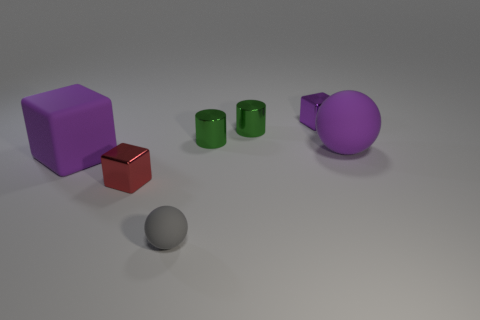Add 2 large brown metallic spheres. How many objects exist? 9 Subtract all cubes. How many objects are left? 4 Add 3 large cubes. How many large cubes exist? 4 Subtract 2 green cylinders. How many objects are left? 5 Subtract all red blocks. Subtract all small purple metallic cubes. How many objects are left? 5 Add 3 tiny green shiny cylinders. How many tiny green shiny cylinders are left? 5 